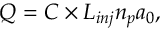Convert formula to latex. <formula><loc_0><loc_0><loc_500><loc_500>Q = C \times L _ { i n j } n _ { p } a _ { 0 } ,</formula> 